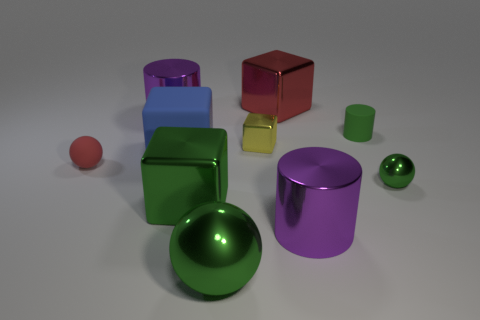Subtract all rubber cylinders. How many cylinders are left? 2 Subtract all blue spheres. How many purple cylinders are left? 2 Subtract all purple cylinders. How many cylinders are left? 1 Subtract all spheres. How many objects are left? 7 Subtract 1 blocks. How many blocks are left? 3 Subtract all large red metal cubes. Subtract all red matte objects. How many objects are left? 8 Add 2 small things. How many small things are left? 6 Add 7 small matte balls. How many small matte balls exist? 8 Subtract 1 red cubes. How many objects are left? 9 Subtract all cyan cylinders. Subtract all cyan spheres. How many cylinders are left? 3 